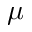<formula> <loc_0><loc_0><loc_500><loc_500>\mu</formula> 